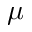<formula> <loc_0><loc_0><loc_500><loc_500>\mu</formula> 